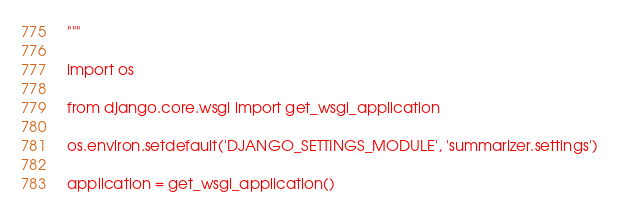<code> <loc_0><loc_0><loc_500><loc_500><_Python_>"""

import os

from django.core.wsgi import get_wsgi_application

os.environ.setdefault('DJANGO_SETTINGS_MODULE', 'summarizer.settings')

application = get_wsgi_application()
</code> 